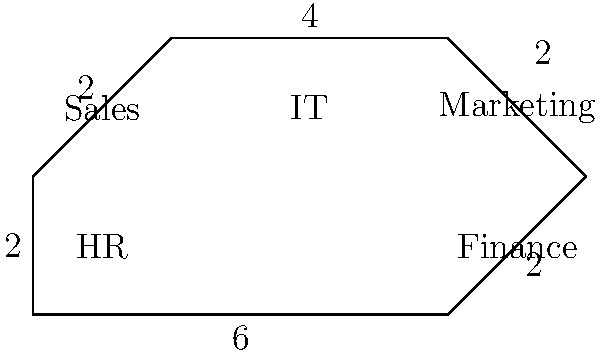An organization chart represents different departments as an irregular polygon. The HR department, where you work, is connected to Sales and Finance. If the lengths between departments are measured in units, with HR to Finance being 6 units, Finance to Marketing 2 units, Marketing to IT 2 units, IT to Sales 4 units, Sales to HR 2 units, and HR to Sales (through a different connection) 2 units, what is the perimeter of the entire organization chart? To calculate the perimeter of the irregular polygon representing the organization chart, we need to sum up all the side lengths:

1. HR to Finance: 6 units
2. Finance to Marketing: 2 units
3. Marketing to IT: 2 units
4. IT to Sales: 4 units
5. Sales to HR (first connection): 2 units
6. HR to Sales (second connection): 2 units

The perimeter is the sum of all these lengths:

$$\text{Perimeter} = 6 + 2 + 2 + 4 + 2 + 2 = 18\text{ units}$$

This calculation gives us the total distance around the organization chart, representing the connections between all departments.
Answer: 18 units 